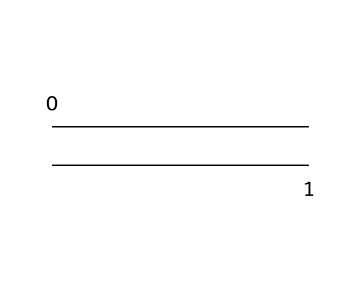What is the chemical symbol for ethylene? Ethylene is represented by the formula C2H4, which can be deduced from its structural representation showing two carbon atoms and four hydrogen atoms attached.
Answer: C2H4 How many carbon atoms are present in ethylene? The SMILES representation C=C indicates that there are two carbon atoms connected by a double bond, clearly showing the number of carbon atoms in the molecule.
Answer: 2 What type of bond connects the carbon atoms in ethylene? The structure C=C shows a double bond between the two carbon atoms, indicating that they are connected by a double bond rather than a single or triple bond.
Answer: double bond What is the hybridization of the carbon atoms in ethylene? In ethylene, each carbon atom forms three sigma bonds (one with the other carbon and two with hydrogen atoms) and has one unhybridized p-orbital involved in the pi bond; thus, the hybridization of each carbon is sp2.
Answer: sp2 What is the degree of unsaturation in ethylene? The degree of unsaturation can be determined from the presence of the double bond (C=C) in the structure, where every double bond indicates one degree of unsaturation, leading to a value of one for ethylene.
Answer: 1 What type of alkene is ethylene classified as based on its structure? Ethylene, having the formula C2H4 and a simple C=C structure without any additional groups or chains, is classified as a simple alkene, specifically an olefin.
Answer: simple alkene 